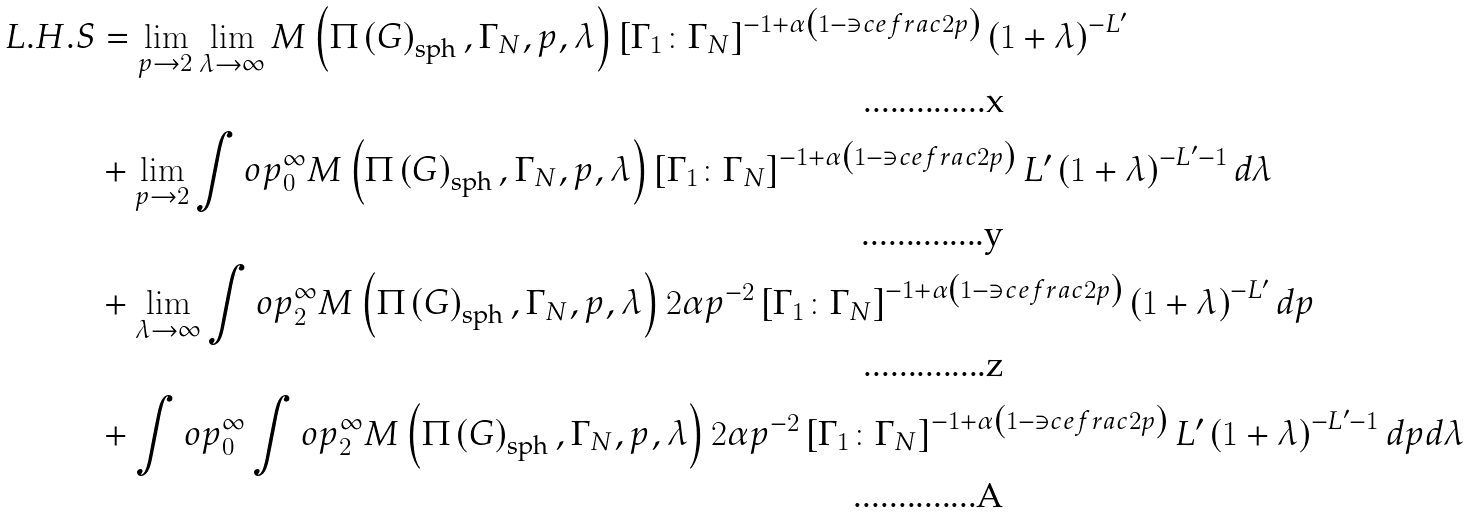<formula> <loc_0><loc_0><loc_500><loc_500>L . H . S & = \lim _ { p \to 2 } \lim _ { \lambda \to \infty } M \left ( \Pi \left ( G \right ) _ { \text {sph} } , \Gamma _ { N } , p , \lambda \right ) \left [ \Gamma _ { 1 } \colon \Gamma _ { N } \right ] ^ { - 1 + \alpha \left ( 1 - \ni c e f r a c { 2 } { p } \right ) } \left ( 1 + \lambda \right ) ^ { - L ^ { \prime } } \\ & + \lim _ { p \to 2 } \int o p _ { 0 } ^ { \infty } M \left ( \Pi \left ( G \right ) _ { \text {sph} } , \Gamma _ { N } , p , \lambda \right ) \left [ \Gamma _ { 1 } \colon \Gamma _ { N } \right ] ^ { - 1 + \alpha \left ( 1 - \ni c e f r a c { 2 } { p } \right ) } L ^ { \prime } \left ( 1 + \lambda \right ) ^ { - L ^ { \prime } - 1 } d \lambda \\ & + \lim _ { \lambda \to \infty } \int o p _ { 2 } ^ { \infty } M \left ( \Pi \left ( G \right ) _ { \text {sph} } , \Gamma _ { N } , p , \lambda \right ) 2 \alpha p ^ { - 2 } \left [ \Gamma _ { 1 } \colon \Gamma _ { N } \right ] ^ { - 1 + \alpha \left ( 1 - \ni c e f r a c { 2 } { p } \right ) } \left ( 1 + \lambda \right ) ^ { - L ^ { \prime } } d p \\ & + \int o p _ { 0 } ^ { \infty } \int o p _ { 2 } ^ { \infty } M \left ( \Pi \left ( G \right ) _ { \text {sph} } , \Gamma _ { N } , p , \lambda \right ) 2 \alpha p ^ { - 2 } \left [ \Gamma _ { 1 } \colon \Gamma _ { N } \right ] ^ { - 1 + \alpha \left ( 1 - \ni c e f r a c { 2 } { p } \right ) } L ^ { \prime } \left ( 1 + \lambda \right ) ^ { - L ^ { \prime } - 1 } d p d \lambda</formula> 